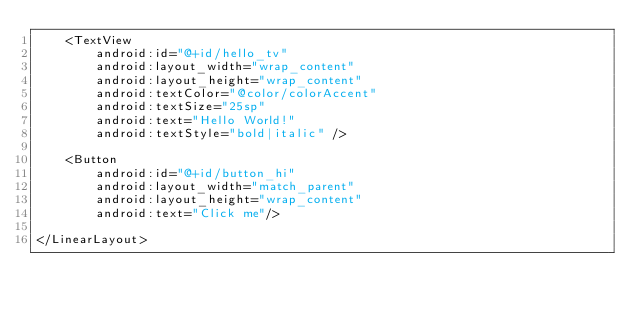<code> <loc_0><loc_0><loc_500><loc_500><_XML_>    <TextView
        android:id="@+id/hello_tv"
        android:layout_width="wrap_content"
        android:layout_height="wrap_content"
        android:textColor="@color/colorAccent"
        android:textSize="25sp"
        android:text="Hello World!"
        android:textStyle="bold|italic" />

    <Button
        android:id="@+id/button_hi"
        android:layout_width="match_parent"
        android:layout_height="wrap_content"
        android:text="Click me"/>

</LinearLayout></code> 